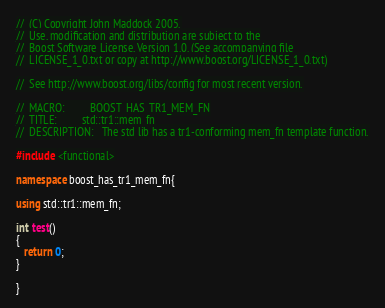Convert code to text. <code><loc_0><loc_0><loc_500><loc_500><_C++_>//  (C) Copyright John Maddock 2005.
//  Use, modification and distribution are subject to the
//  Boost Software License, Version 1.0. (See accompanying file
//  LICENSE_1_0.txt or copy at http://www.boost.org/LICENSE_1_0.txt)

//  See http://www.boost.org/libs/config for most recent version.

//  MACRO:         BOOST_HAS_TR1_MEM_FN
//  TITLE:         std::tr1::mem_fn
//  DESCRIPTION:   The std lib has a tr1-conforming mem_fn template function.

#include <functional>

namespace boost_has_tr1_mem_fn{

using std::tr1::mem_fn;

int test()
{
   return 0;
}

}
</code> 